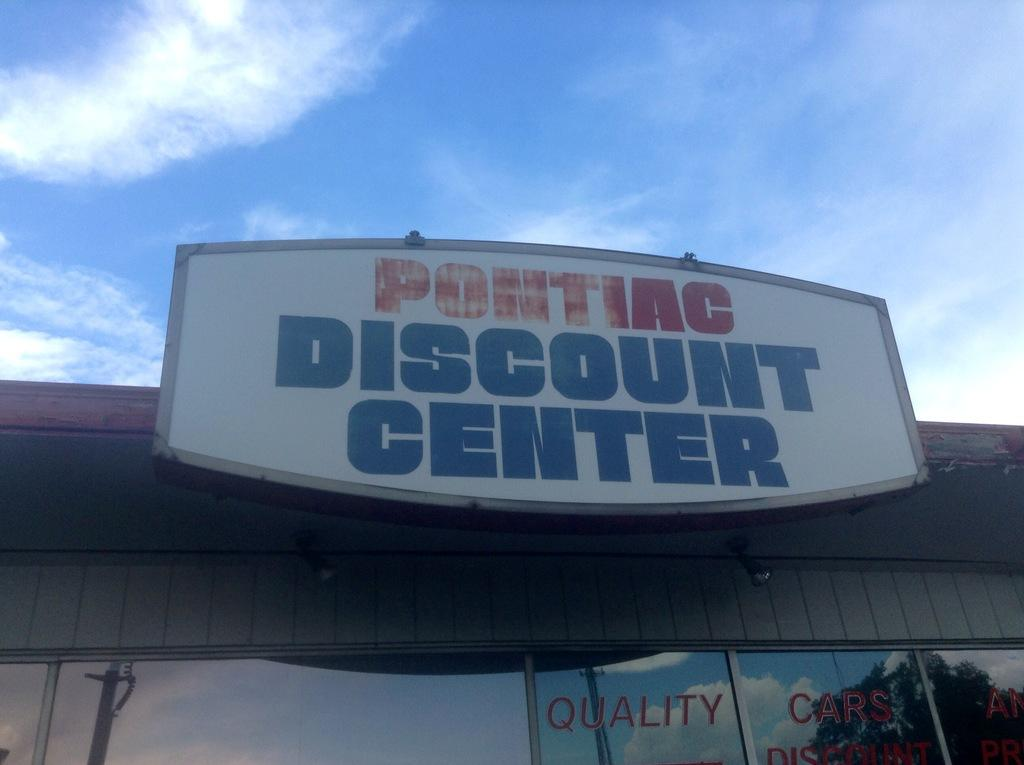<image>
Write a terse but informative summary of the picture. You can find quality cars at the Pontiac Discount Center. 